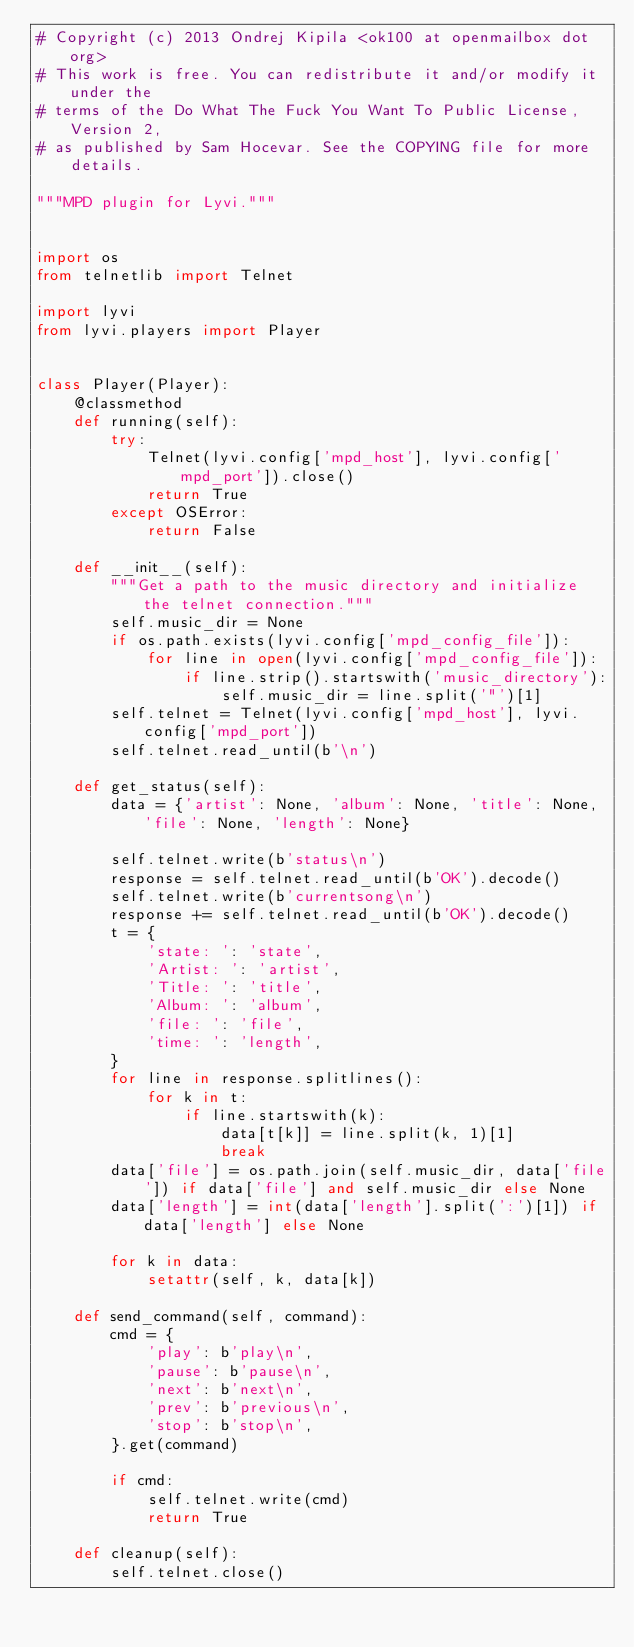<code> <loc_0><loc_0><loc_500><loc_500><_Python_># Copyright (c) 2013 Ondrej Kipila <ok100 at openmailbox dot org>
# This work is free. You can redistribute it and/or modify it under the
# terms of the Do What The Fuck You Want To Public License, Version 2,
# as published by Sam Hocevar. See the COPYING file for more details.

"""MPD plugin for Lyvi."""


import os
from telnetlib import Telnet

import lyvi
from lyvi.players import Player


class Player(Player):
    @classmethod
    def running(self):
        try:
            Telnet(lyvi.config['mpd_host'], lyvi.config['mpd_port']).close()
            return True
        except OSError:
            return False

    def __init__(self):
        """Get a path to the music directory and initialize the telnet connection."""
        self.music_dir = None
        if os.path.exists(lyvi.config['mpd_config_file']):
            for line in open(lyvi.config['mpd_config_file']):
                if line.strip().startswith('music_directory'):
                    self.music_dir = line.split('"')[1]
        self.telnet = Telnet(lyvi.config['mpd_host'], lyvi.config['mpd_port'])
        self.telnet.read_until(b'\n')

    def get_status(self):
        data = {'artist': None, 'album': None, 'title': None, 'file': None, 'length': None}

        self.telnet.write(b'status\n')
        response = self.telnet.read_until(b'OK').decode()
        self.telnet.write(b'currentsong\n')
        response += self.telnet.read_until(b'OK').decode()
        t = {
            'state: ': 'state',
            'Artist: ': 'artist',
            'Title: ': 'title',
            'Album: ': 'album',
            'file: ': 'file',
            'time: ': 'length',
        }
        for line in response.splitlines():
            for k in t:
                if line.startswith(k):
                    data[t[k]] = line.split(k, 1)[1]
                    break
        data['file'] = os.path.join(self.music_dir, data['file']) if data['file'] and self.music_dir else None
        data['length'] = int(data['length'].split(':')[1]) if data['length'] else None

        for k in data:
            setattr(self, k, data[k])

    def send_command(self, command):
        cmd = {
            'play': b'play\n',
            'pause': b'pause\n',
            'next': b'next\n',
            'prev': b'previous\n',
            'stop': b'stop\n',
        }.get(command)

        if cmd:
            self.telnet.write(cmd)
            return True

    def cleanup(self):
        self.telnet.close()
</code> 